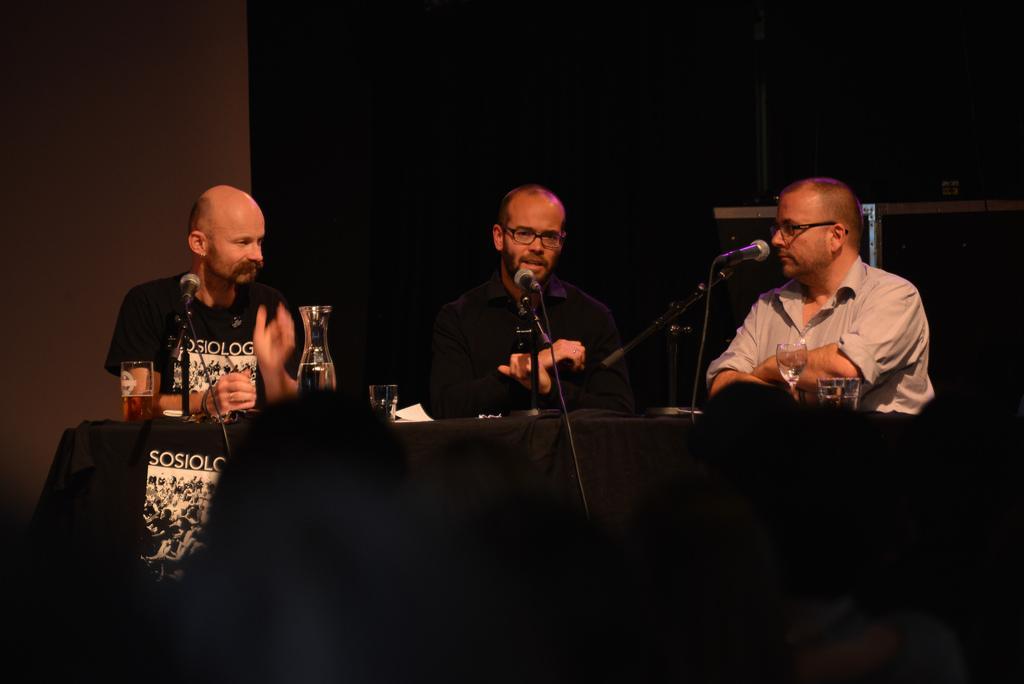How would you summarize this image in a sentence or two? In the center of the image we can see three people sitting, before them there is a table and we can see glasses, paper, jug and mics placed on the table. In the background there is a curtain and a wall. 